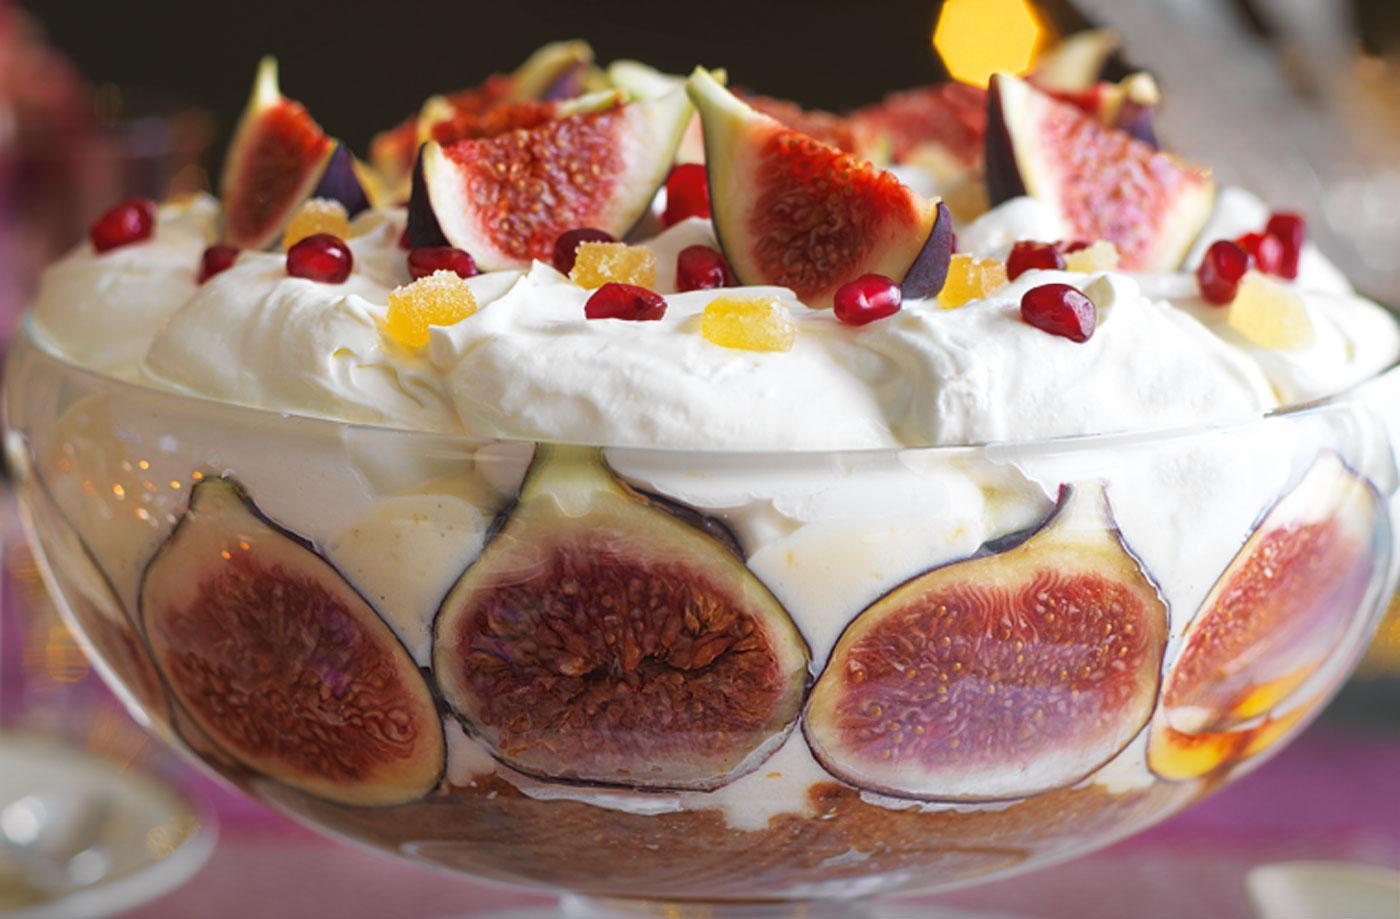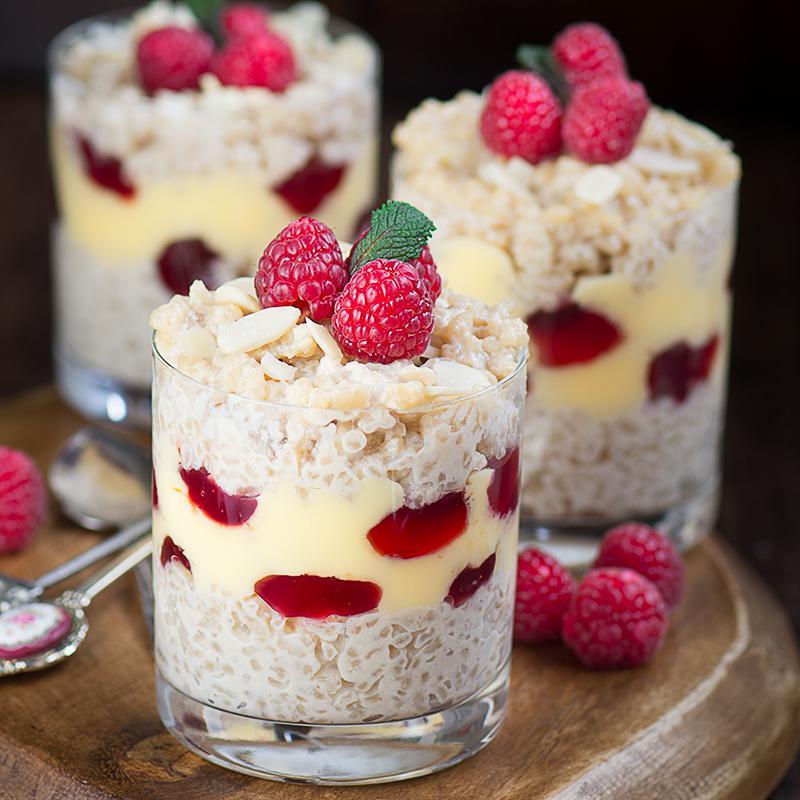The first image is the image on the left, the second image is the image on the right. Assess this claim about the two images: "There is white flatware with a ribbon tied around it.". Correct or not? Answer yes or no. No. 